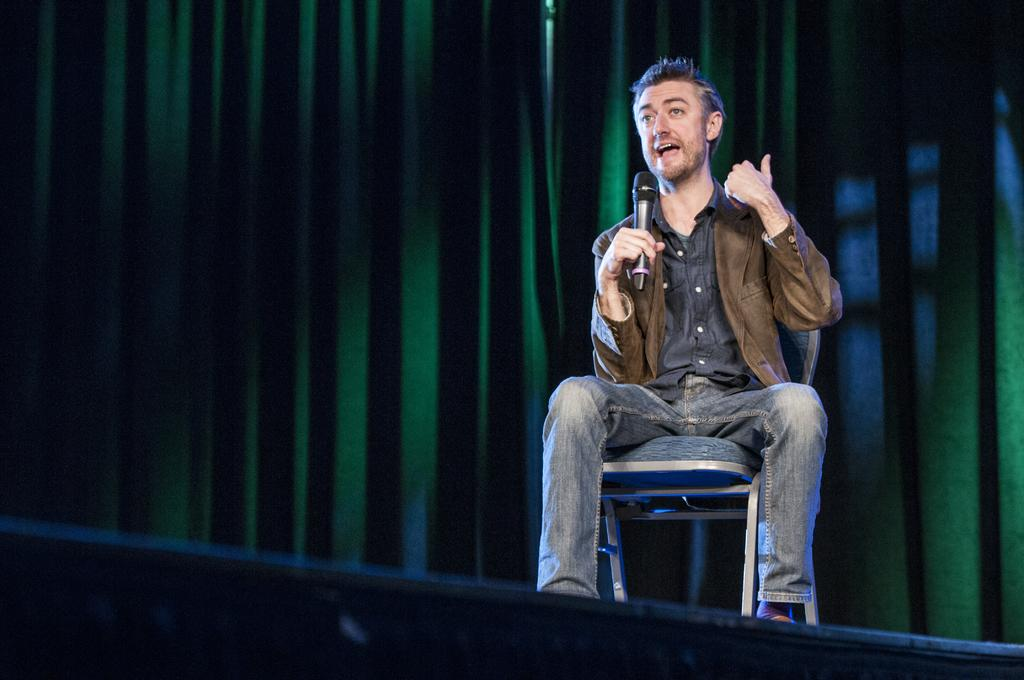What is the person in the image doing? The person is sitting on a chair and talking. What object is the person holding in the image? The person is holding a microphone. What can be seen in the background of the image? There is a curtain in the background of the image. What type of dirt can be seen on the person's shoes in the image? There is no dirt visible on the person's shoes in the image, as the person's shoes are not shown. What thoughts might the person be expressing while talking in the image? We cannot determine the person's thoughts from the image, as thoughts are not visible. 